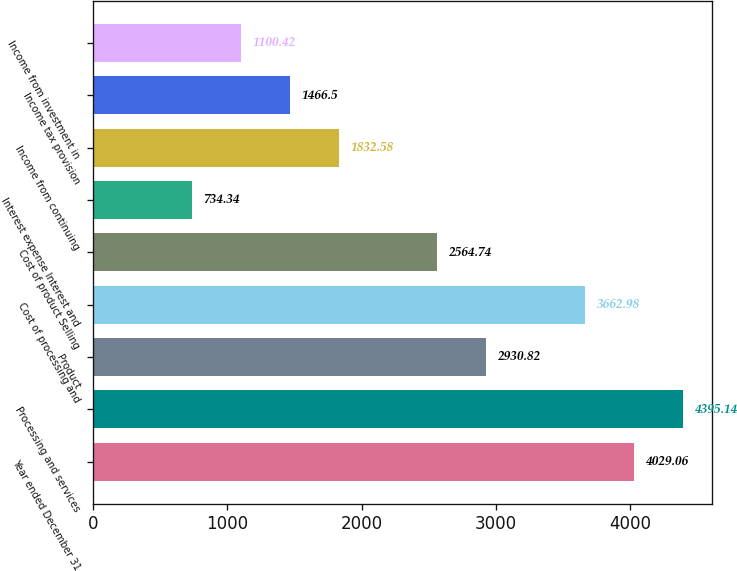Convert chart to OTSL. <chart><loc_0><loc_0><loc_500><loc_500><bar_chart><fcel>Year ended December 31<fcel>Processing and services<fcel>Product<fcel>Cost of processing and<fcel>Cost of product Selling<fcel>Interest expense Interest and<fcel>Income from continuing<fcel>Income tax provision<fcel>Income from investment in<nl><fcel>4029.06<fcel>4395.14<fcel>2930.82<fcel>3662.98<fcel>2564.74<fcel>734.34<fcel>1832.58<fcel>1466.5<fcel>1100.42<nl></chart> 